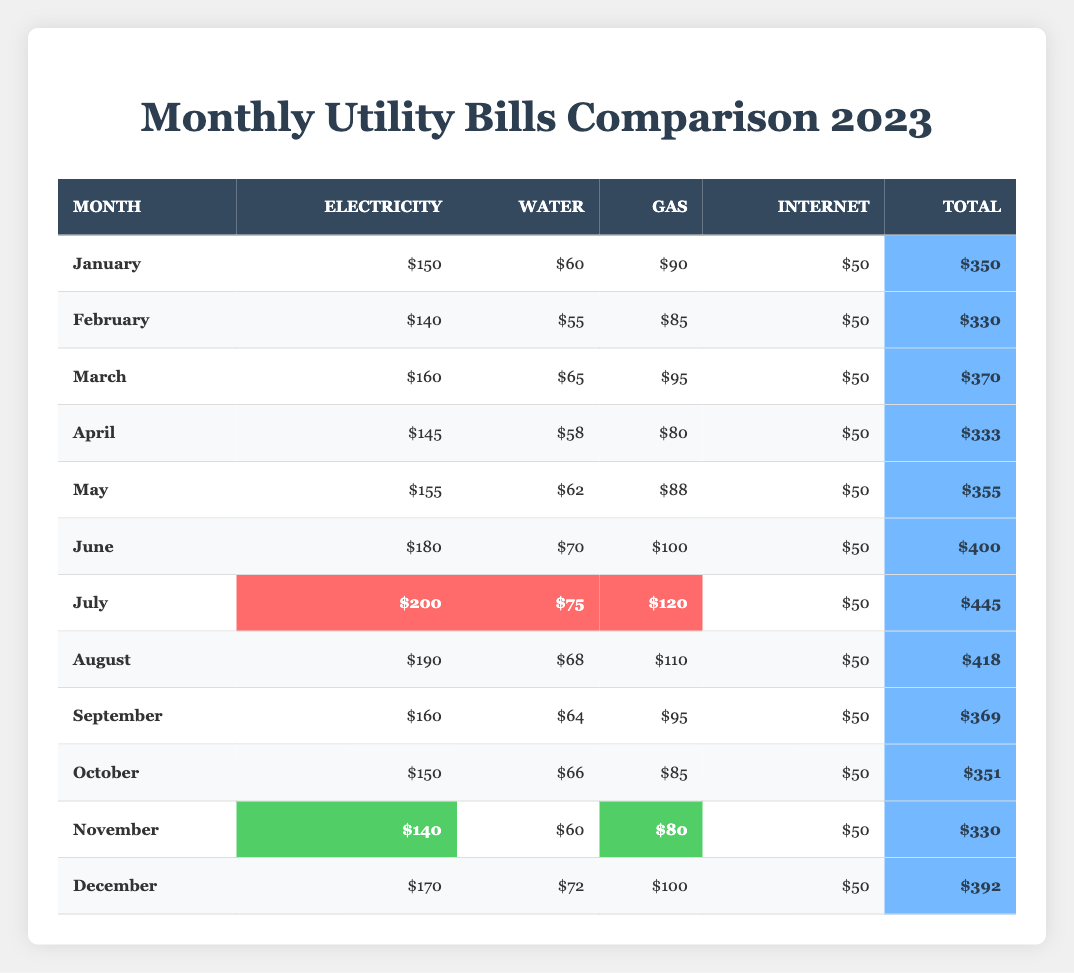What is the total utility bill for the month of July? In the table, the total utility bill for July is specifically listed as $445.
Answer: $445 Which month had the highest electricity bill? By reviewing the electricity bills for each month, July has the highest electricity bill at $200.
Answer: July What is the average total bill for the year? To find the average total bill, we first sum all the total bills: (350 + 330 + 370 + 333 + 355 + 400 + 445 + 418 + 369 + 351 + 330 + 392 = 4,095). Since there are 12 months, we divide this total by 12, which gives us approximately $341.25.
Answer: $341.25 In which month was the water bill the lowest? By looking at the water bills for each month, February has the lowest water bill at $55.
Answer: February What is the difference between the highest and lowest total bills? The highest total bill is in July at $445, and the lowest is in February at $330. The difference is $445 - $330 = $115.
Answer: $115 Was the gas bill higher in June than in December? In June, the gas bill is $100 and in December, it is also $100. Since both amounts are equal, we conclude that the gas bill was not higher in June than in December.
Answer: No What is the total amount spent on internet bills for the year? Each month has an internet bill of $50, and since there are 12 months, the total is $50 * 12 = $600.
Answer: $600 Which month had the second-highest total utility bill? The total bill amounts for each month are reviewed, and the second-highest is August at $418, following July's $445.
Answer: August What was the average electricity bill for the first half of the year (January to June)? The electricity bills from January to June are $150, $140, $160, $145, $155, and $180. Their sum is $150 + $140 + $160 + $145 + $155 + $180 = $930. Dividing by the 6 months gives an average of $155.
Answer: $155 Was the total bill for November higher than the total bill for April? November's total bill is $330 and April's total bill is $333. Since $330 is less than $333, the total bill in November was not higher than in April.
Answer: No 